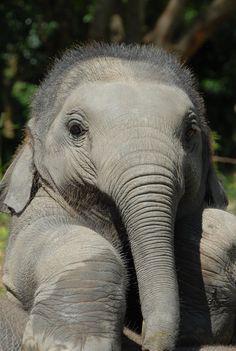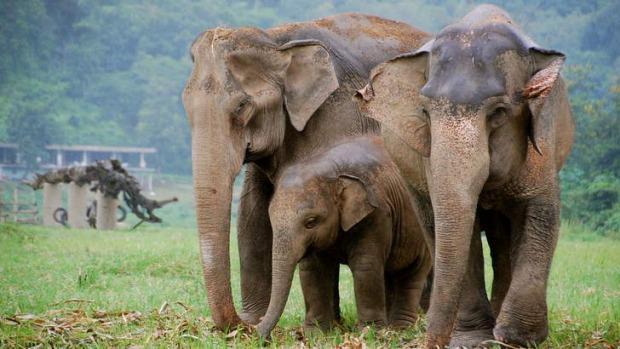The first image is the image on the left, the second image is the image on the right. Assess this claim about the two images: "An image shows a young elephant standing next to at least one adult elephant.". Correct or not? Answer yes or no. Yes. The first image is the image on the left, the second image is the image on the right. Given the left and right images, does the statement "An enclosure is seen behind one of the elephants." hold true? Answer yes or no. No. 